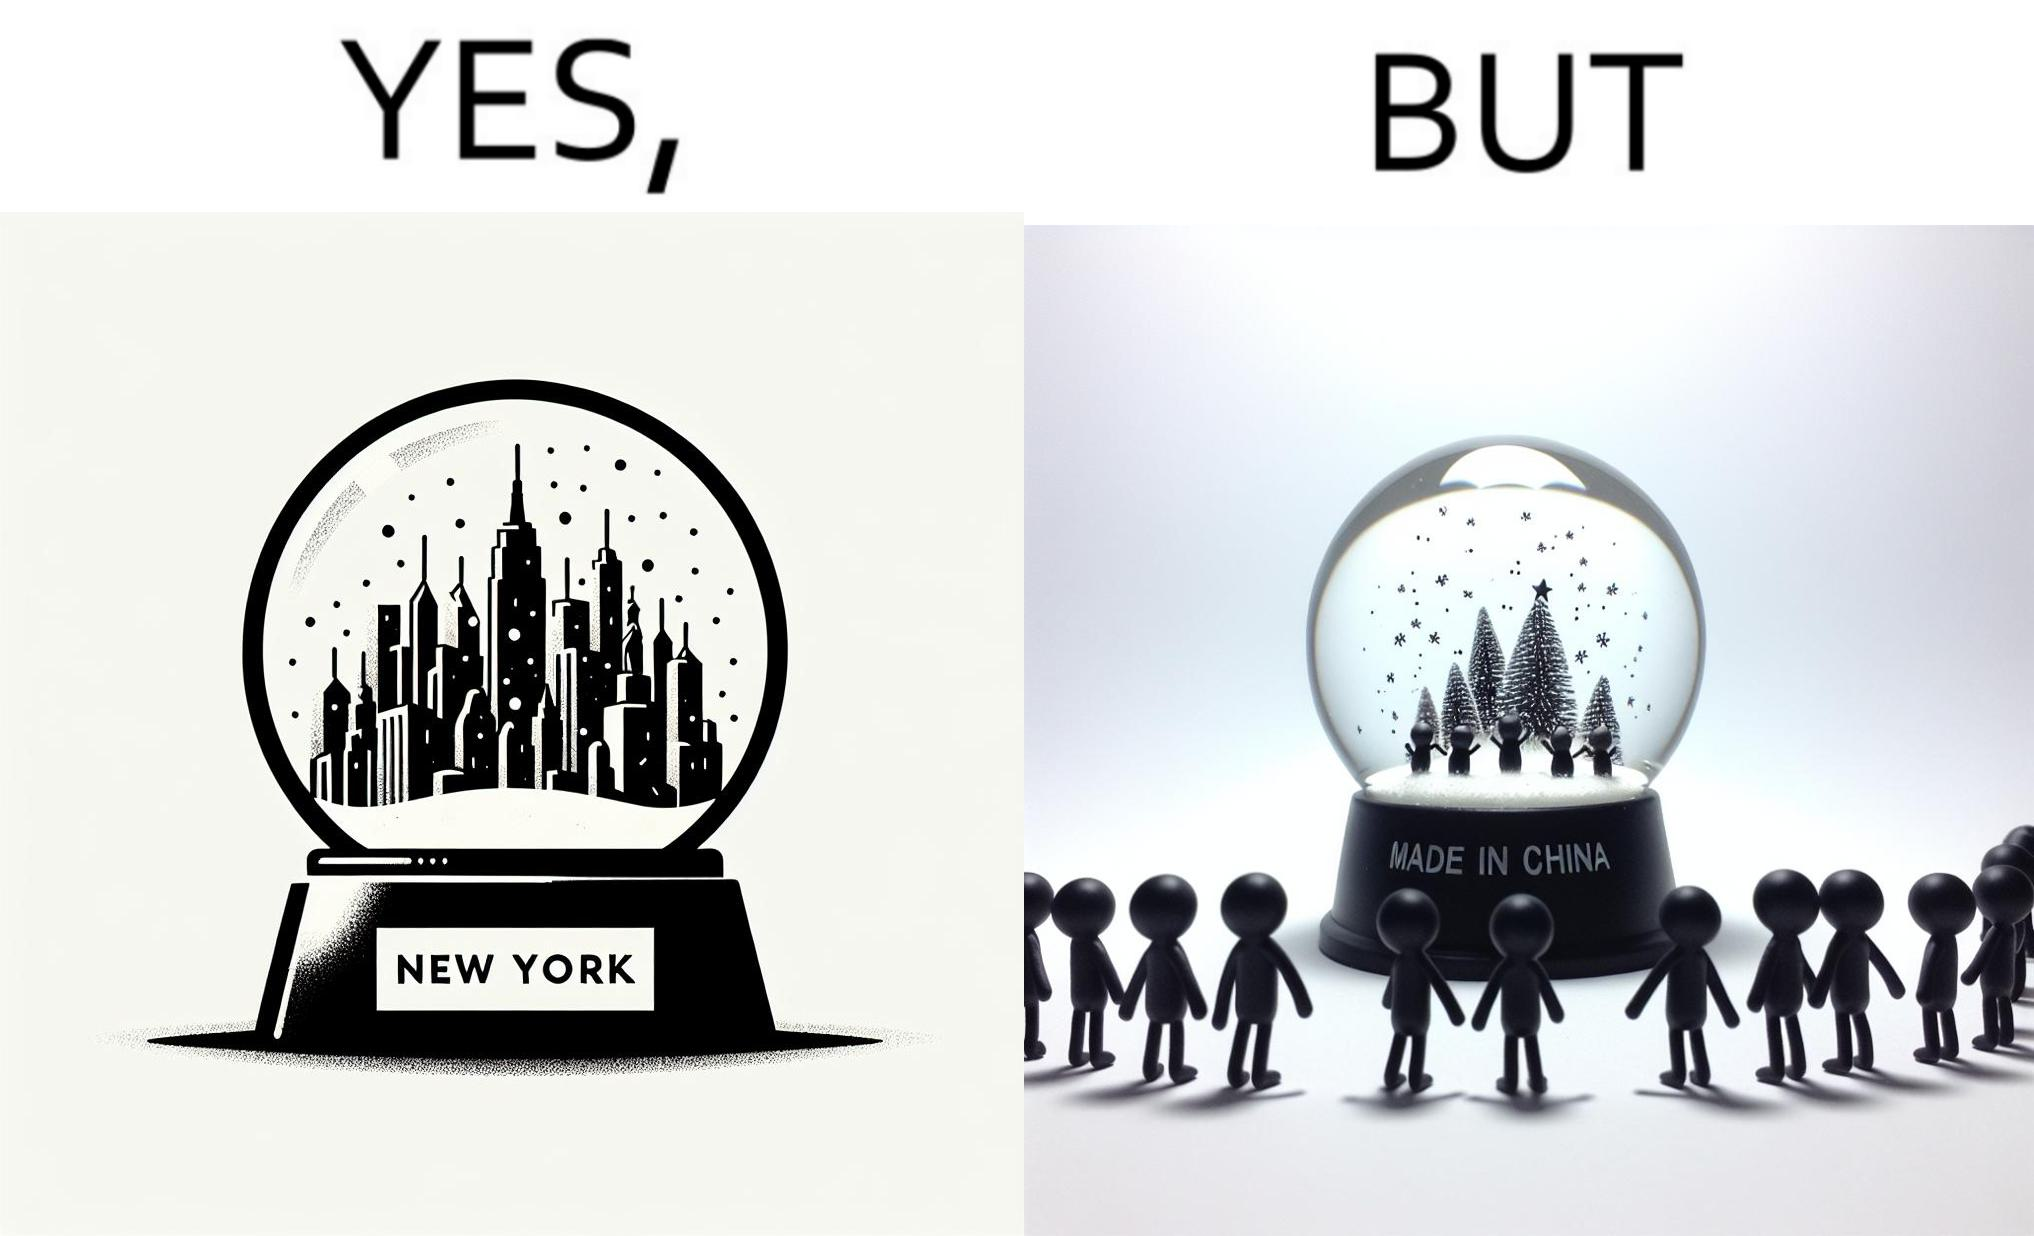Would you classify this image as satirical? Yes, this image is satirical. 